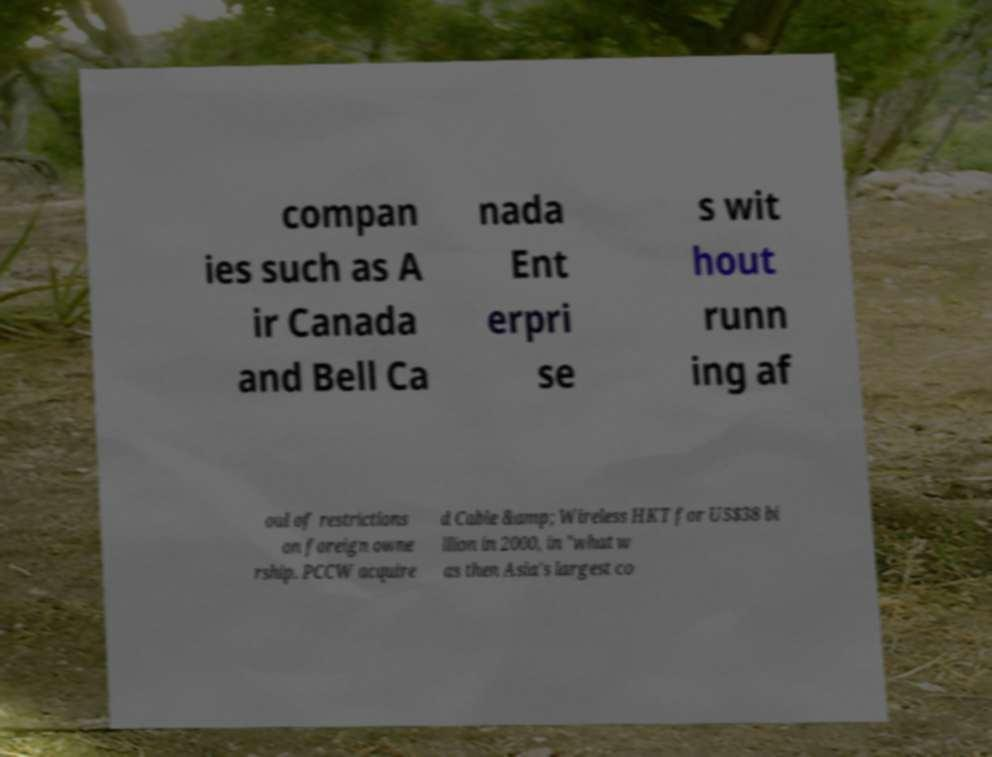Can you accurately transcribe the text from the provided image for me? compan ies such as A ir Canada and Bell Ca nada Ent erpri se s wit hout runn ing af oul of restrictions on foreign owne rship. PCCW acquire d Cable &amp; Wireless HKT for US$38 bi llion in 2000, in "what w as then Asia's largest co 